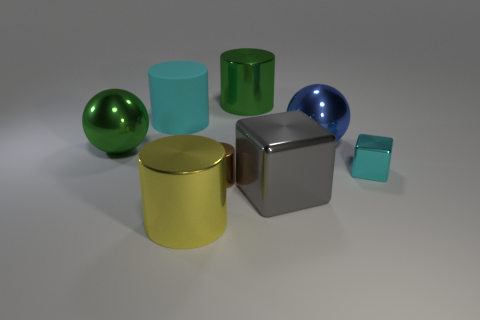What shape is the small shiny thing that is the same color as the large matte object? cube 